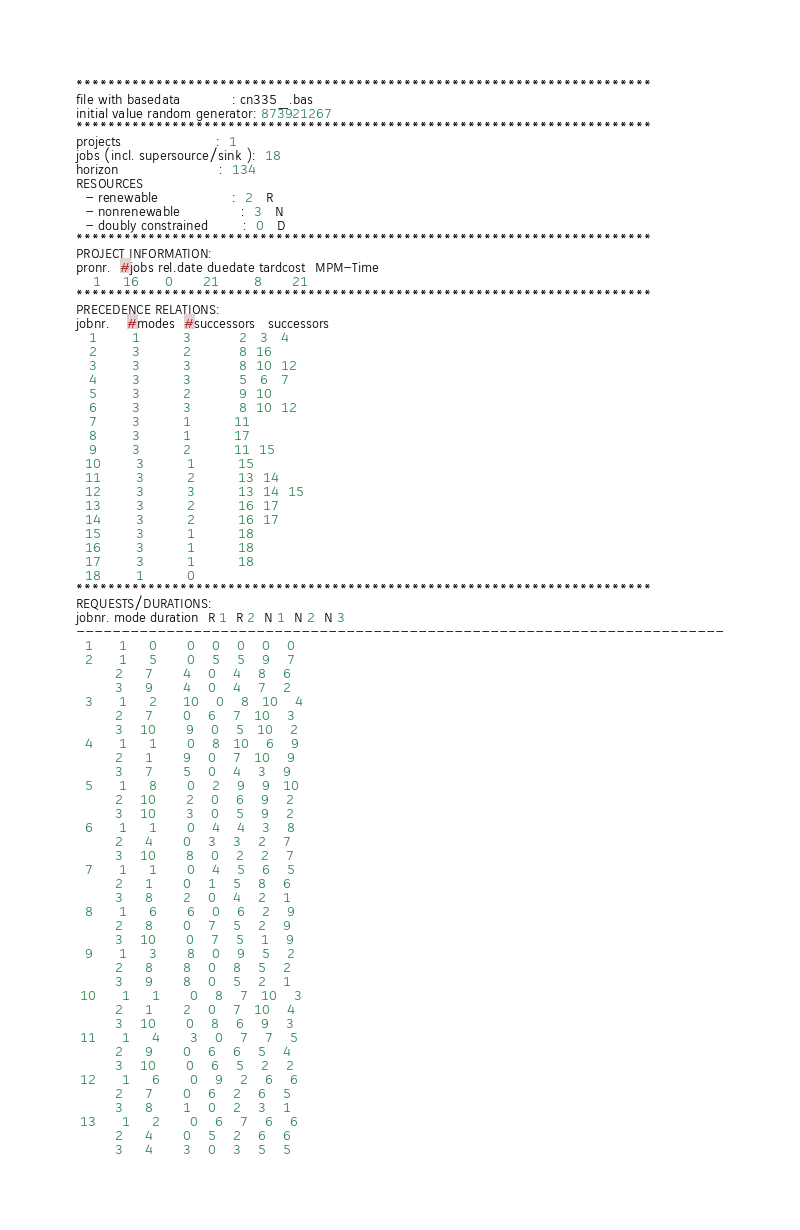Convert code to text. <code><loc_0><loc_0><loc_500><loc_500><_ObjectiveC_>************************************************************************
file with basedata            : cn335_.bas
initial value random generator: 873921267
************************************************************************
projects                      :  1
jobs (incl. supersource/sink ):  18
horizon                       :  134
RESOURCES
  - renewable                 :  2   R
  - nonrenewable              :  3   N
  - doubly constrained        :  0   D
************************************************************************
PROJECT INFORMATION:
pronr.  #jobs rel.date duedate tardcost  MPM-Time
    1     16      0       21        8       21
************************************************************************
PRECEDENCE RELATIONS:
jobnr.    #modes  #successors   successors
   1        1          3           2   3   4
   2        3          2           8  16
   3        3          3           8  10  12
   4        3          3           5   6   7
   5        3          2           9  10
   6        3          3           8  10  12
   7        3          1          11
   8        3          1          17
   9        3          2          11  15
  10        3          1          15
  11        3          2          13  14
  12        3          3          13  14  15
  13        3          2          16  17
  14        3          2          16  17
  15        3          1          18
  16        3          1          18
  17        3          1          18
  18        1          0        
************************************************************************
REQUESTS/DURATIONS:
jobnr. mode duration  R 1  R 2  N 1  N 2  N 3
------------------------------------------------------------------------
  1      1     0       0    0    0    0    0
  2      1     5       0    5    5    9    7
         2     7       4    0    4    8    6
         3     9       4    0    4    7    2
  3      1     2      10    0    8   10    4
         2     7       0    6    7   10    3
         3    10       9    0    5   10    2
  4      1     1       0    8   10    6    9
         2     1       9    0    7   10    9
         3     7       5    0    4    3    9
  5      1     8       0    2    9    9   10
         2    10       2    0    6    9    2
         3    10       3    0    5    9    2
  6      1     1       0    4    4    3    8
         2     4       0    3    3    2    7
         3    10       8    0    2    2    7
  7      1     1       0    4    5    6    5
         2     1       0    1    5    8    6
         3     8       2    0    4    2    1
  8      1     6       6    0    6    2    9
         2     8       0    7    5    2    9
         3    10       0    7    5    1    9
  9      1     3       8    0    9    5    2
         2     8       8    0    8    5    2
         3     9       8    0    5    2    1
 10      1     1       0    8    7   10    3
         2     1       2    0    7   10    4
         3    10       0    8    6    9    3
 11      1     4       3    0    7    7    5
         2     9       0    6    6    5    4
         3    10       0    6    5    2    2
 12      1     6       0    9    2    6    6
         2     7       0    6    2    6    5
         3     8       1    0    2    3    1
 13      1     2       0    6    7    6    6
         2     4       0    5    2    6    6
         3     4       3    0    3    5    5</code> 